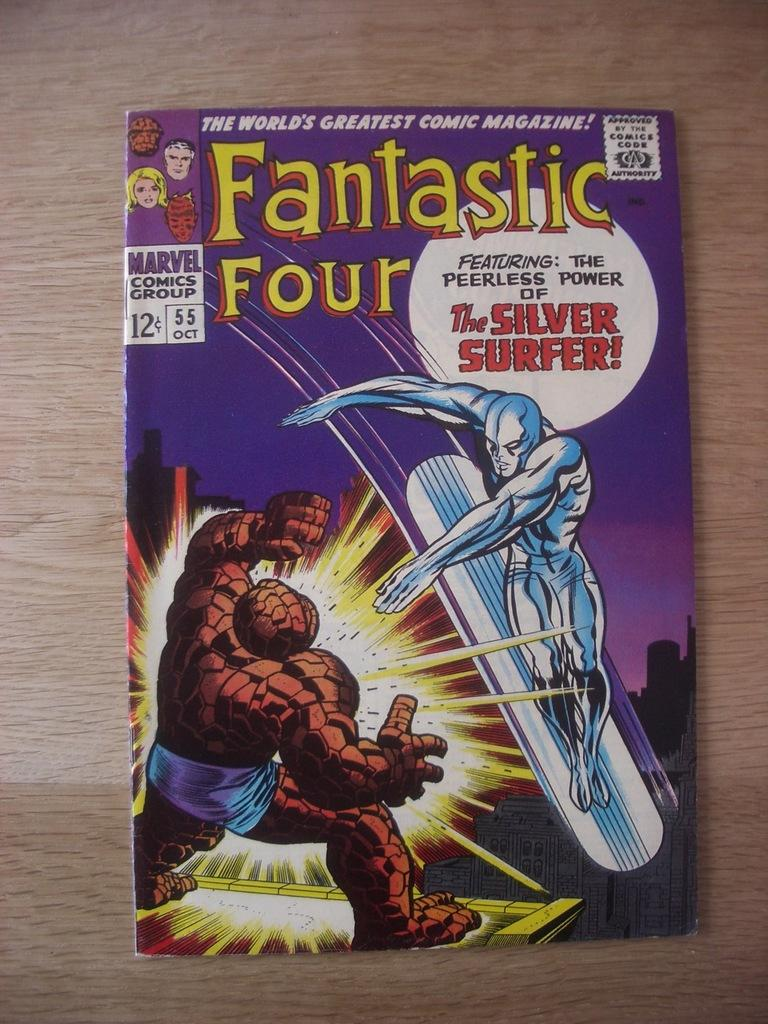<image>
Describe the image concisely. A Fantastic Four comic shows the Silver Surfer on the cover. 